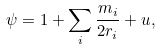Convert formula to latex. <formula><loc_0><loc_0><loc_500><loc_500>\psi = 1 + \sum _ { i } \frac { m _ { i } } { 2 r _ { i } } + u ,</formula> 